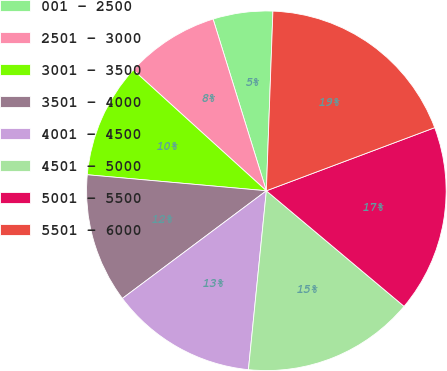Convert chart to OTSL. <chart><loc_0><loc_0><loc_500><loc_500><pie_chart><fcel>001 - 2500<fcel>2501 - 3000<fcel>3001 - 3500<fcel>3501 - 4000<fcel>4001 - 4500<fcel>4501 - 5000<fcel>5001 - 5500<fcel>5501 - 6000<nl><fcel>5.37%<fcel>8.48%<fcel>10.31%<fcel>11.64%<fcel>13.19%<fcel>15.48%<fcel>16.82%<fcel>18.71%<nl></chart> 